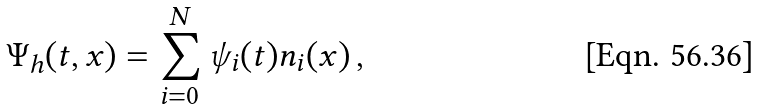<formula> <loc_0><loc_0><loc_500><loc_500>\Psi _ { h } ( t , x ) = \sum _ { i = 0 } ^ { N } \psi _ { i } ( t ) n _ { i } ( x ) \, ,</formula> 